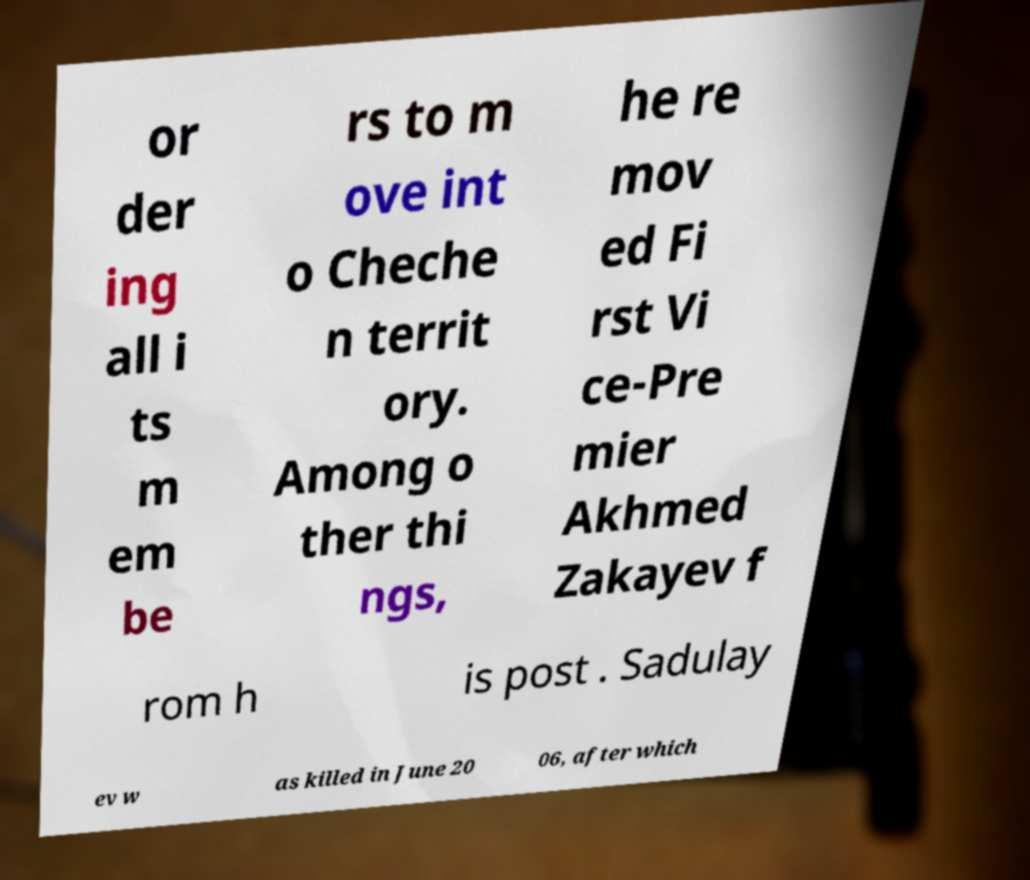What messages or text are displayed in this image? I need them in a readable, typed format. or der ing all i ts m em be rs to m ove int o Cheche n territ ory. Among o ther thi ngs, he re mov ed Fi rst Vi ce-Pre mier Akhmed Zakayev f rom h is post . Sadulay ev w as killed in June 20 06, after which 